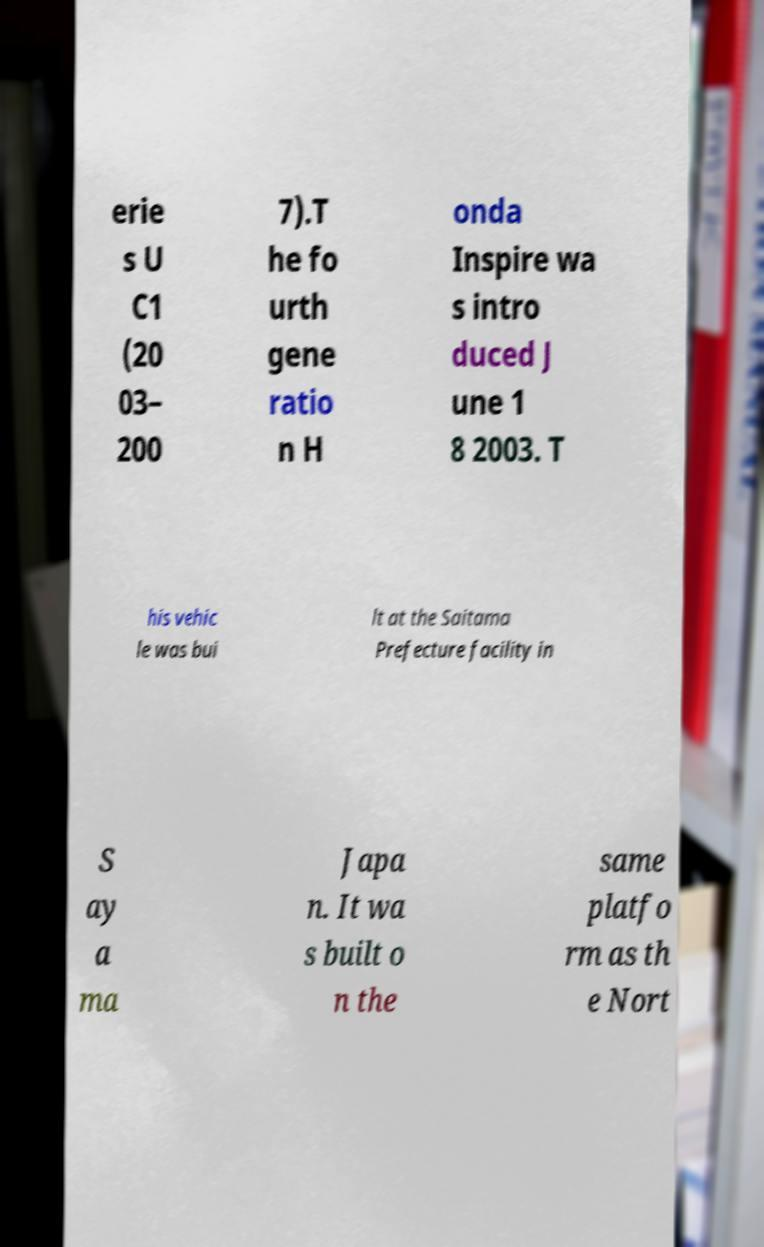Can you read and provide the text displayed in the image?This photo seems to have some interesting text. Can you extract and type it out for me? erie s U C1 (20 03– 200 7).T he fo urth gene ratio n H onda Inspire wa s intro duced J une 1 8 2003. T his vehic le was bui lt at the Saitama Prefecture facility in S ay a ma Japa n. It wa s built o n the same platfo rm as th e Nort 